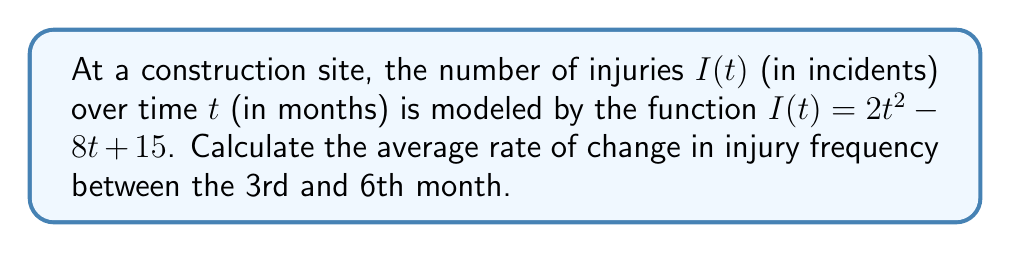Can you solve this math problem? To calculate the average rate of change between two points, we use the formula:

$$\text{Average rate of change} = \frac{f(b) - f(a)}{b - a}$$

Where $a$ and $b$ are the initial and final time points, respectively.

1) First, let's calculate $I(3)$ and $I(6)$:

   $I(3) = 2(3)^2 - 8(3) + 15 = 18 - 24 + 15 = 9$ injuries
   $I(6) = 2(6)^2 - 8(6) + 15 = 72 - 48 + 15 = 39$ injuries

2) Now, we can substitute these values into our formula:

   $$\text{Average rate of change} = \frac{I(6) - I(3)}{6 - 3} = \frac{39 - 9}{3} = \frac{30}{3} = 10$$

3) Therefore, the average rate of change in injury frequency between the 3rd and 6th month is 10 injuries per month.
Answer: 10 injuries/month 